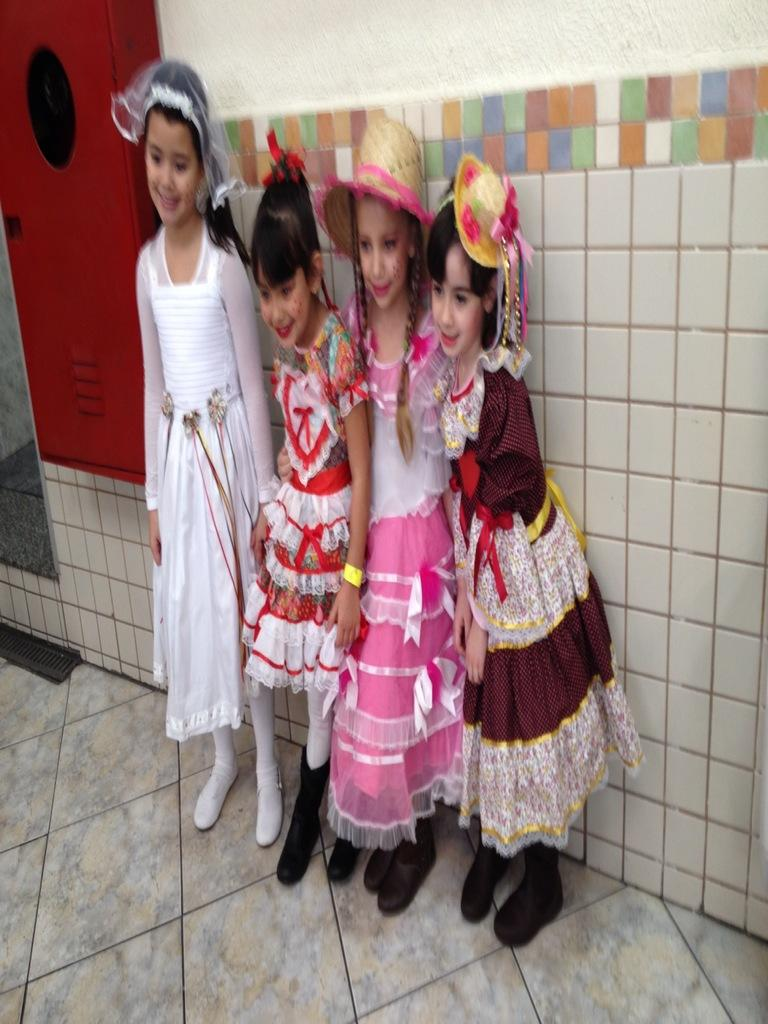How many girls are present in the image? There are 4 girls in the image. What can be observed about the girls' attire? The girls are wearing different costumes. What are the girls doing in the image? The girls are standing and looking at someone. What type of property can be seen in the background of the image? There is no property visible in the background of the image. Can you tell me what the girls are saying in the image? The image does not provide any information about what the girls are saying, as it only shows their appearance and actions. 